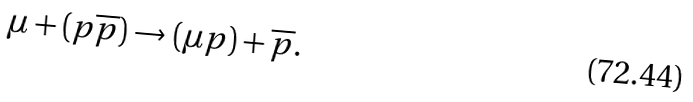<formula> <loc_0><loc_0><loc_500><loc_500>\mu + ( p \overline { p } ) \rightarrow ( \mu p ) + \overline { p } .</formula> 